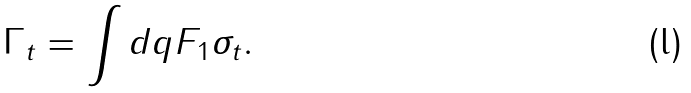Convert formula to latex. <formula><loc_0><loc_0><loc_500><loc_500>\Gamma _ { t } = \int d { q } F _ { 1 } \sigma _ { t } .</formula> 